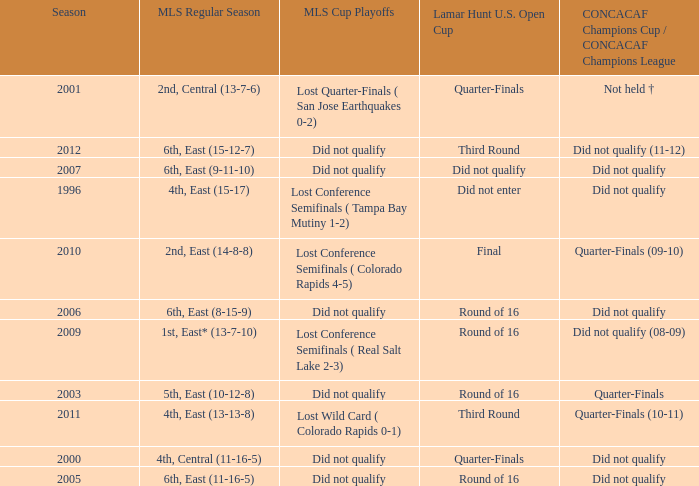What was the mls cup playoffs when the mls regular season was 4th, central (11-16-5)? Did not qualify. 